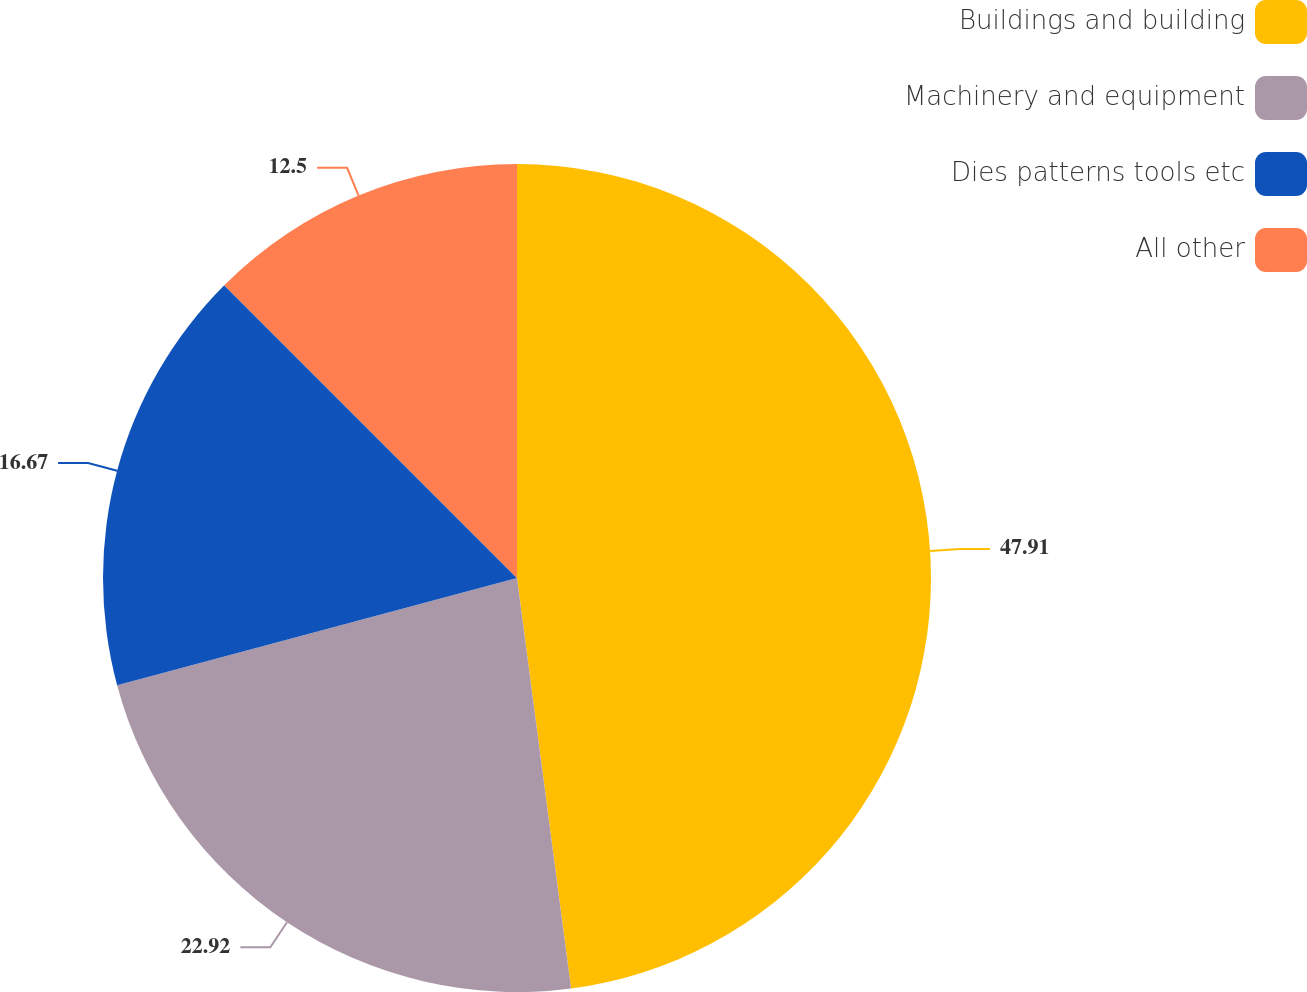Convert chart. <chart><loc_0><loc_0><loc_500><loc_500><pie_chart><fcel>Buildings and building<fcel>Machinery and equipment<fcel>Dies patterns tools etc<fcel>All other<nl><fcel>47.92%<fcel>22.92%<fcel>16.67%<fcel>12.5%<nl></chart> 